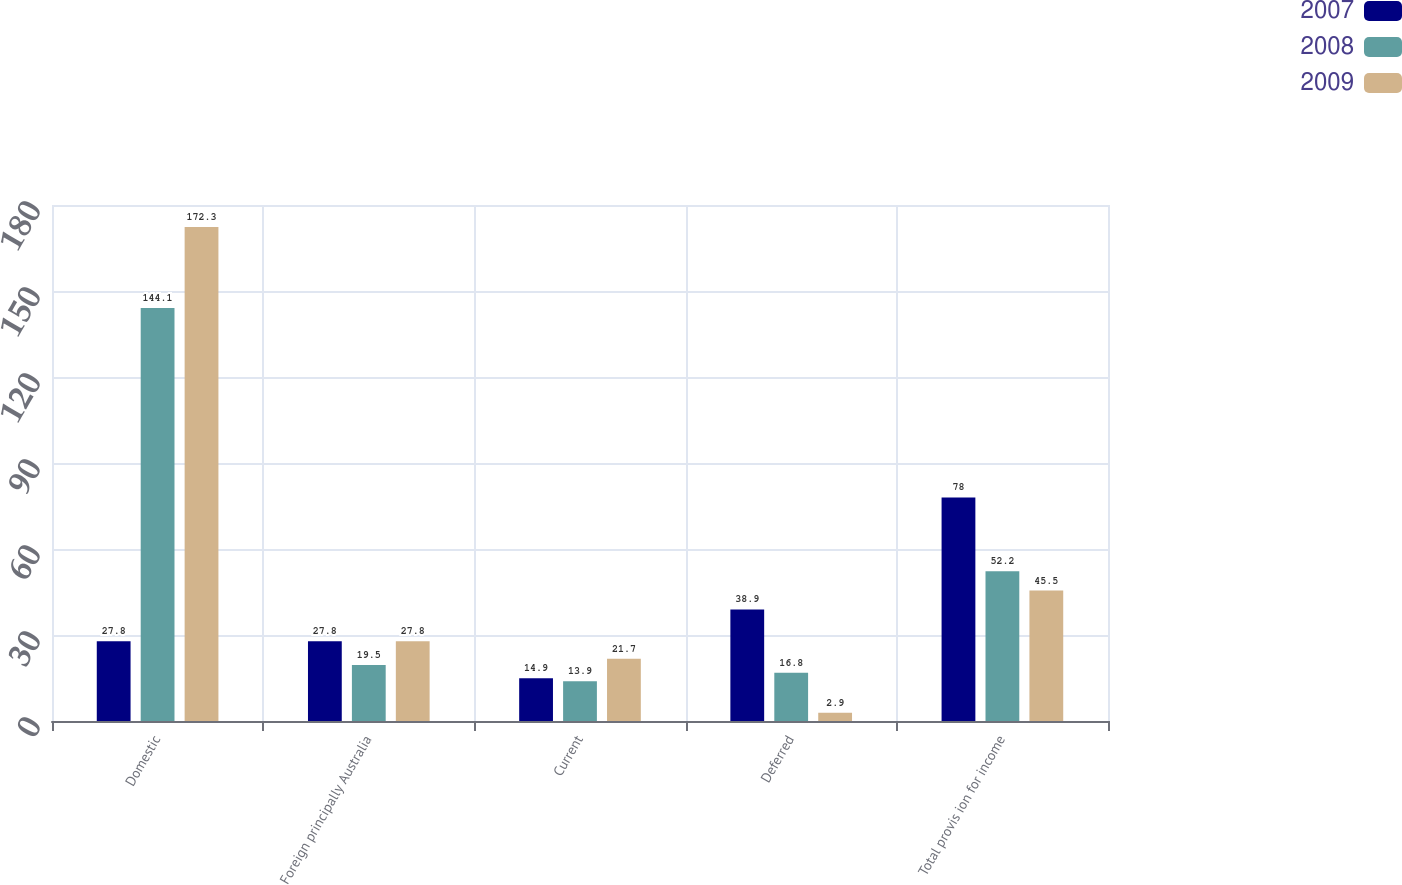<chart> <loc_0><loc_0><loc_500><loc_500><stacked_bar_chart><ecel><fcel>Domestic<fcel>Foreign principally Australia<fcel>Current<fcel>Deferred<fcel>Total provis ion for income<nl><fcel>2007<fcel>27.8<fcel>27.8<fcel>14.9<fcel>38.9<fcel>78<nl><fcel>2008<fcel>144.1<fcel>19.5<fcel>13.9<fcel>16.8<fcel>52.2<nl><fcel>2009<fcel>172.3<fcel>27.8<fcel>21.7<fcel>2.9<fcel>45.5<nl></chart> 